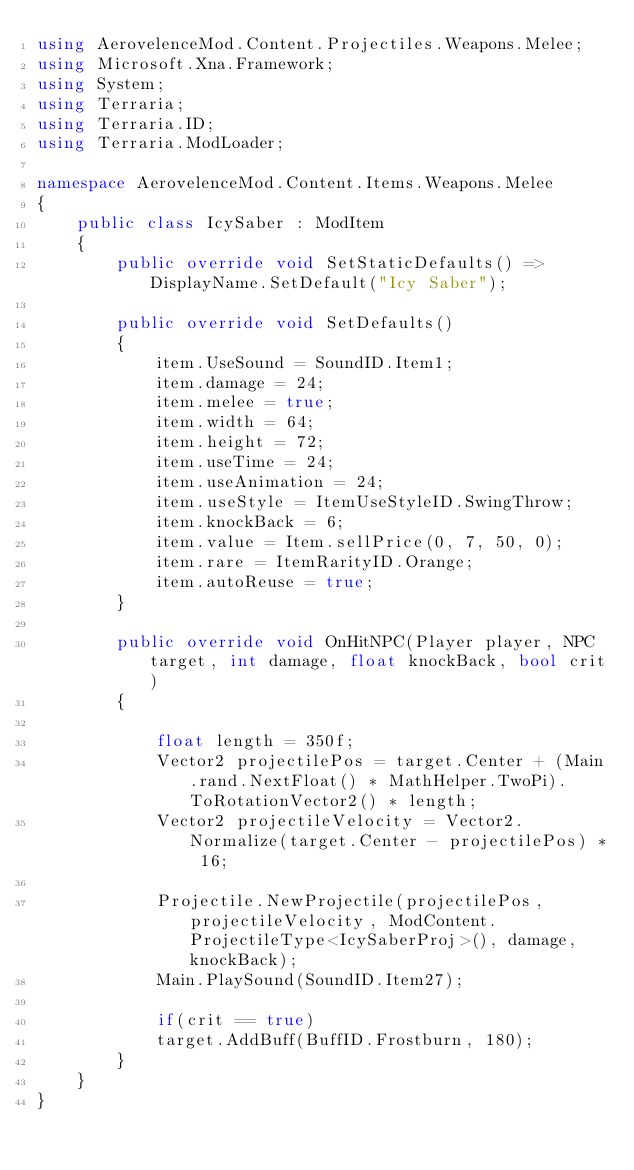<code> <loc_0><loc_0><loc_500><loc_500><_C#_>using AerovelenceMod.Content.Projectiles.Weapons.Melee;
using Microsoft.Xna.Framework;
using System;
using Terraria;
using Terraria.ID;
using Terraria.ModLoader;

namespace AerovelenceMod.Content.Items.Weapons.Melee
{
    public class IcySaber : ModItem
    {
        public override void SetStaticDefaults() => DisplayName.SetDefault("Icy Saber");

        public override void SetDefaults()
        {
            item.UseSound = SoundID.Item1;
            item.damage = 24;
            item.melee = true;
            item.width = 64;
            item.height = 72;
            item.useTime = 24;
            item.useAnimation = 24;
            item.useStyle = ItemUseStyleID.SwingThrow;
            item.knockBack = 6;
            item.value = Item.sellPrice(0, 7, 50, 0);
            item.rare = ItemRarityID.Orange;
            item.autoReuse = true;
        }

        public override void OnHitNPC(Player player, NPC target, int damage, float knockBack, bool crit)
        {

            float length = 350f;
            Vector2 projectilePos = target.Center + (Main.rand.NextFloat() * MathHelper.TwoPi).ToRotationVector2() * length;
            Vector2 projectileVelocity = Vector2.Normalize(target.Center - projectilePos) * 16;

            Projectile.NewProjectile(projectilePos, projectileVelocity, ModContent.ProjectileType<IcySaberProj>(), damage, knockBack);
            Main.PlaySound(SoundID.Item27);

            if(crit == true)
            target.AddBuff(BuffID.Frostburn, 180);
        }
    }
}</code> 